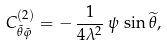Convert formula to latex. <formula><loc_0><loc_0><loc_500><loc_500>C ^ { ( 2 ) } _ { \tilde { \theta } \tilde { \varphi } } = - \, \frac { 1 } { 4 \lambda ^ { 2 } } \, \psi \, \sin { \widetilde { \theta } } ,</formula> 